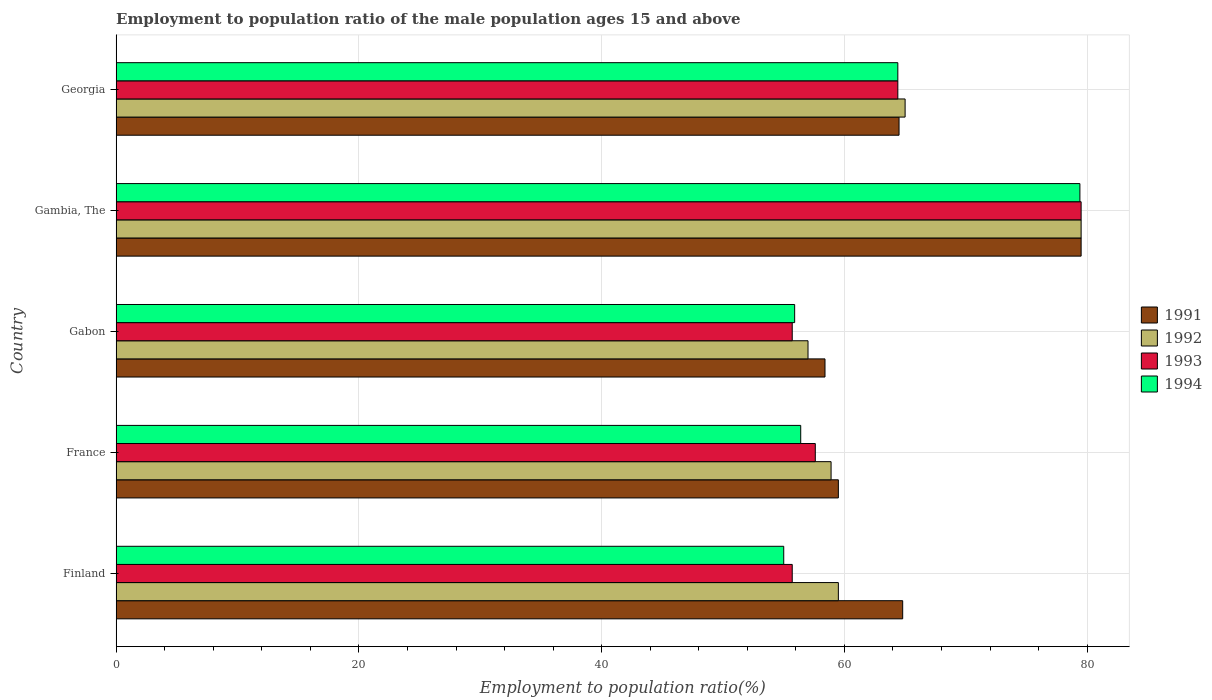How many different coloured bars are there?
Your response must be concise. 4. How many groups of bars are there?
Give a very brief answer. 5. How many bars are there on the 4th tick from the bottom?
Offer a very short reply. 4. What is the label of the 1st group of bars from the top?
Offer a terse response. Georgia. In how many cases, is the number of bars for a given country not equal to the number of legend labels?
Give a very brief answer. 0. Across all countries, what is the maximum employment to population ratio in 1994?
Your answer should be compact. 79.4. Across all countries, what is the minimum employment to population ratio in 1994?
Make the answer very short. 55. In which country was the employment to population ratio in 1992 maximum?
Ensure brevity in your answer.  Gambia, The. In which country was the employment to population ratio in 1994 minimum?
Provide a short and direct response. Finland. What is the total employment to population ratio in 1993 in the graph?
Your answer should be very brief. 312.9. What is the difference between the employment to population ratio in 1994 in Finland and that in Gabon?
Provide a succinct answer. -0.9. What is the difference between the employment to population ratio in 1991 in Georgia and the employment to population ratio in 1992 in France?
Your answer should be compact. 5.6. What is the average employment to population ratio in 1992 per country?
Provide a short and direct response. 63.98. What is the difference between the employment to population ratio in 1991 and employment to population ratio in 1992 in Gabon?
Your answer should be compact. 1.4. What is the ratio of the employment to population ratio in 1994 in France to that in Gabon?
Keep it short and to the point. 1.01. Is the difference between the employment to population ratio in 1991 in Gambia, The and Georgia greater than the difference between the employment to population ratio in 1992 in Gambia, The and Georgia?
Offer a terse response. Yes. Is it the case that in every country, the sum of the employment to population ratio in 1991 and employment to population ratio in 1994 is greater than the sum of employment to population ratio in 1993 and employment to population ratio in 1992?
Your answer should be compact. No. What does the 2nd bar from the top in Gabon represents?
Your response must be concise. 1993. What does the 3rd bar from the bottom in Georgia represents?
Give a very brief answer. 1993. Is it the case that in every country, the sum of the employment to population ratio in 1992 and employment to population ratio in 1991 is greater than the employment to population ratio in 1994?
Make the answer very short. Yes. Are all the bars in the graph horizontal?
Offer a terse response. Yes. What is the title of the graph?
Provide a succinct answer. Employment to population ratio of the male population ages 15 and above. What is the label or title of the X-axis?
Your response must be concise. Employment to population ratio(%). What is the Employment to population ratio(%) of 1991 in Finland?
Provide a succinct answer. 64.8. What is the Employment to population ratio(%) in 1992 in Finland?
Your response must be concise. 59.5. What is the Employment to population ratio(%) of 1993 in Finland?
Offer a very short reply. 55.7. What is the Employment to population ratio(%) of 1994 in Finland?
Offer a terse response. 55. What is the Employment to population ratio(%) of 1991 in France?
Your answer should be compact. 59.5. What is the Employment to population ratio(%) in 1992 in France?
Offer a very short reply. 58.9. What is the Employment to population ratio(%) of 1993 in France?
Your response must be concise. 57.6. What is the Employment to population ratio(%) of 1994 in France?
Provide a succinct answer. 56.4. What is the Employment to population ratio(%) of 1991 in Gabon?
Your response must be concise. 58.4. What is the Employment to population ratio(%) of 1992 in Gabon?
Offer a terse response. 57. What is the Employment to population ratio(%) of 1993 in Gabon?
Keep it short and to the point. 55.7. What is the Employment to population ratio(%) of 1994 in Gabon?
Your answer should be very brief. 55.9. What is the Employment to population ratio(%) of 1991 in Gambia, The?
Provide a short and direct response. 79.5. What is the Employment to population ratio(%) in 1992 in Gambia, The?
Offer a very short reply. 79.5. What is the Employment to population ratio(%) in 1993 in Gambia, The?
Your answer should be very brief. 79.5. What is the Employment to population ratio(%) of 1994 in Gambia, The?
Keep it short and to the point. 79.4. What is the Employment to population ratio(%) of 1991 in Georgia?
Give a very brief answer. 64.5. What is the Employment to population ratio(%) in 1993 in Georgia?
Offer a terse response. 64.4. What is the Employment to population ratio(%) in 1994 in Georgia?
Keep it short and to the point. 64.4. Across all countries, what is the maximum Employment to population ratio(%) of 1991?
Your response must be concise. 79.5. Across all countries, what is the maximum Employment to population ratio(%) of 1992?
Offer a terse response. 79.5. Across all countries, what is the maximum Employment to population ratio(%) of 1993?
Provide a short and direct response. 79.5. Across all countries, what is the maximum Employment to population ratio(%) in 1994?
Provide a short and direct response. 79.4. Across all countries, what is the minimum Employment to population ratio(%) in 1991?
Keep it short and to the point. 58.4. Across all countries, what is the minimum Employment to population ratio(%) in 1993?
Provide a succinct answer. 55.7. Across all countries, what is the minimum Employment to population ratio(%) of 1994?
Offer a terse response. 55. What is the total Employment to population ratio(%) of 1991 in the graph?
Your answer should be compact. 326.7. What is the total Employment to population ratio(%) in 1992 in the graph?
Offer a very short reply. 319.9. What is the total Employment to population ratio(%) of 1993 in the graph?
Ensure brevity in your answer.  312.9. What is the total Employment to population ratio(%) in 1994 in the graph?
Make the answer very short. 311.1. What is the difference between the Employment to population ratio(%) of 1994 in Finland and that in France?
Offer a terse response. -1.4. What is the difference between the Employment to population ratio(%) in 1991 in Finland and that in Gabon?
Your answer should be compact. 6.4. What is the difference between the Employment to population ratio(%) of 1992 in Finland and that in Gabon?
Keep it short and to the point. 2.5. What is the difference between the Employment to population ratio(%) of 1991 in Finland and that in Gambia, The?
Provide a short and direct response. -14.7. What is the difference between the Employment to population ratio(%) of 1992 in Finland and that in Gambia, The?
Make the answer very short. -20. What is the difference between the Employment to population ratio(%) of 1993 in Finland and that in Gambia, The?
Provide a short and direct response. -23.8. What is the difference between the Employment to population ratio(%) of 1994 in Finland and that in Gambia, The?
Offer a terse response. -24.4. What is the difference between the Employment to population ratio(%) in 1991 in Finland and that in Georgia?
Provide a succinct answer. 0.3. What is the difference between the Employment to population ratio(%) of 1993 in Finland and that in Georgia?
Offer a very short reply. -8.7. What is the difference between the Employment to population ratio(%) of 1993 in France and that in Gabon?
Give a very brief answer. 1.9. What is the difference between the Employment to population ratio(%) of 1991 in France and that in Gambia, The?
Provide a succinct answer. -20. What is the difference between the Employment to population ratio(%) in 1992 in France and that in Gambia, The?
Keep it short and to the point. -20.6. What is the difference between the Employment to population ratio(%) in 1993 in France and that in Gambia, The?
Your answer should be compact. -21.9. What is the difference between the Employment to population ratio(%) of 1994 in France and that in Gambia, The?
Give a very brief answer. -23. What is the difference between the Employment to population ratio(%) of 1992 in France and that in Georgia?
Offer a very short reply. -6.1. What is the difference between the Employment to population ratio(%) of 1991 in Gabon and that in Gambia, The?
Make the answer very short. -21.1. What is the difference between the Employment to population ratio(%) of 1992 in Gabon and that in Gambia, The?
Offer a terse response. -22.5. What is the difference between the Employment to population ratio(%) in 1993 in Gabon and that in Gambia, The?
Keep it short and to the point. -23.8. What is the difference between the Employment to population ratio(%) in 1994 in Gabon and that in Gambia, The?
Offer a terse response. -23.5. What is the difference between the Employment to population ratio(%) of 1991 in Gabon and that in Georgia?
Give a very brief answer. -6.1. What is the difference between the Employment to population ratio(%) in 1994 in Gabon and that in Georgia?
Your response must be concise. -8.5. What is the difference between the Employment to population ratio(%) of 1993 in Gambia, The and that in Georgia?
Give a very brief answer. 15.1. What is the difference between the Employment to population ratio(%) of 1991 in Finland and the Employment to population ratio(%) of 1994 in France?
Provide a succinct answer. 8.4. What is the difference between the Employment to population ratio(%) of 1992 in Finland and the Employment to population ratio(%) of 1994 in France?
Give a very brief answer. 3.1. What is the difference between the Employment to population ratio(%) of 1991 in Finland and the Employment to population ratio(%) of 1992 in Gabon?
Ensure brevity in your answer.  7.8. What is the difference between the Employment to population ratio(%) of 1991 in Finland and the Employment to population ratio(%) of 1993 in Gabon?
Make the answer very short. 9.1. What is the difference between the Employment to population ratio(%) in 1993 in Finland and the Employment to population ratio(%) in 1994 in Gabon?
Keep it short and to the point. -0.2. What is the difference between the Employment to population ratio(%) in 1991 in Finland and the Employment to population ratio(%) in 1992 in Gambia, The?
Provide a succinct answer. -14.7. What is the difference between the Employment to population ratio(%) in 1991 in Finland and the Employment to population ratio(%) in 1993 in Gambia, The?
Offer a very short reply. -14.7. What is the difference between the Employment to population ratio(%) of 1991 in Finland and the Employment to population ratio(%) of 1994 in Gambia, The?
Give a very brief answer. -14.6. What is the difference between the Employment to population ratio(%) in 1992 in Finland and the Employment to population ratio(%) in 1993 in Gambia, The?
Give a very brief answer. -20. What is the difference between the Employment to population ratio(%) in 1992 in Finland and the Employment to population ratio(%) in 1994 in Gambia, The?
Offer a terse response. -19.9. What is the difference between the Employment to population ratio(%) in 1993 in Finland and the Employment to population ratio(%) in 1994 in Gambia, The?
Your answer should be compact. -23.7. What is the difference between the Employment to population ratio(%) in 1991 in Finland and the Employment to population ratio(%) in 1992 in Georgia?
Offer a very short reply. -0.2. What is the difference between the Employment to population ratio(%) of 1991 in Finland and the Employment to population ratio(%) of 1994 in Georgia?
Make the answer very short. 0.4. What is the difference between the Employment to population ratio(%) in 1992 in Finland and the Employment to population ratio(%) in 1993 in Georgia?
Your answer should be compact. -4.9. What is the difference between the Employment to population ratio(%) in 1992 in Finland and the Employment to population ratio(%) in 1994 in Georgia?
Keep it short and to the point. -4.9. What is the difference between the Employment to population ratio(%) of 1991 in France and the Employment to population ratio(%) of 1992 in Gabon?
Keep it short and to the point. 2.5. What is the difference between the Employment to population ratio(%) in 1991 in France and the Employment to population ratio(%) in 1994 in Gabon?
Provide a succinct answer. 3.6. What is the difference between the Employment to population ratio(%) in 1992 in France and the Employment to population ratio(%) in 1993 in Gabon?
Your answer should be compact. 3.2. What is the difference between the Employment to population ratio(%) of 1992 in France and the Employment to population ratio(%) of 1994 in Gabon?
Your answer should be very brief. 3. What is the difference between the Employment to population ratio(%) of 1993 in France and the Employment to population ratio(%) of 1994 in Gabon?
Your response must be concise. 1.7. What is the difference between the Employment to population ratio(%) of 1991 in France and the Employment to population ratio(%) of 1992 in Gambia, The?
Give a very brief answer. -20. What is the difference between the Employment to population ratio(%) in 1991 in France and the Employment to population ratio(%) in 1993 in Gambia, The?
Provide a short and direct response. -20. What is the difference between the Employment to population ratio(%) of 1991 in France and the Employment to population ratio(%) of 1994 in Gambia, The?
Your answer should be compact. -19.9. What is the difference between the Employment to population ratio(%) of 1992 in France and the Employment to population ratio(%) of 1993 in Gambia, The?
Provide a succinct answer. -20.6. What is the difference between the Employment to population ratio(%) in 1992 in France and the Employment to population ratio(%) in 1994 in Gambia, The?
Provide a succinct answer. -20.5. What is the difference between the Employment to population ratio(%) in 1993 in France and the Employment to population ratio(%) in 1994 in Gambia, The?
Give a very brief answer. -21.8. What is the difference between the Employment to population ratio(%) of 1991 in France and the Employment to population ratio(%) of 1993 in Georgia?
Offer a very short reply. -4.9. What is the difference between the Employment to population ratio(%) of 1992 in France and the Employment to population ratio(%) of 1993 in Georgia?
Offer a terse response. -5.5. What is the difference between the Employment to population ratio(%) of 1992 in France and the Employment to population ratio(%) of 1994 in Georgia?
Your answer should be compact. -5.5. What is the difference between the Employment to population ratio(%) in 1993 in France and the Employment to population ratio(%) in 1994 in Georgia?
Your answer should be very brief. -6.8. What is the difference between the Employment to population ratio(%) of 1991 in Gabon and the Employment to population ratio(%) of 1992 in Gambia, The?
Give a very brief answer. -21.1. What is the difference between the Employment to population ratio(%) of 1991 in Gabon and the Employment to population ratio(%) of 1993 in Gambia, The?
Your answer should be very brief. -21.1. What is the difference between the Employment to population ratio(%) of 1992 in Gabon and the Employment to population ratio(%) of 1993 in Gambia, The?
Offer a terse response. -22.5. What is the difference between the Employment to population ratio(%) of 1992 in Gabon and the Employment to population ratio(%) of 1994 in Gambia, The?
Ensure brevity in your answer.  -22.4. What is the difference between the Employment to population ratio(%) in 1993 in Gabon and the Employment to population ratio(%) in 1994 in Gambia, The?
Ensure brevity in your answer.  -23.7. What is the difference between the Employment to population ratio(%) in 1991 in Gabon and the Employment to population ratio(%) in 1994 in Georgia?
Provide a short and direct response. -6. What is the difference between the Employment to population ratio(%) of 1992 in Gabon and the Employment to population ratio(%) of 1994 in Georgia?
Your answer should be very brief. -7.4. What is the difference between the Employment to population ratio(%) in 1991 in Gambia, The and the Employment to population ratio(%) in 1994 in Georgia?
Provide a short and direct response. 15.1. What is the difference between the Employment to population ratio(%) of 1992 in Gambia, The and the Employment to population ratio(%) of 1993 in Georgia?
Your answer should be compact. 15.1. What is the difference between the Employment to population ratio(%) of 1992 in Gambia, The and the Employment to population ratio(%) of 1994 in Georgia?
Keep it short and to the point. 15.1. What is the average Employment to population ratio(%) in 1991 per country?
Ensure brevity in your answer.  65.34. What is the average Employment to population ratio(%) in 1992 per country?
Your answer should be very brief. 63.98. What is the average Employment to population ratio(%) of 1993 per country?
Offer a very short reply. 62.58. What is the average Employment to population ratio(%) in 1994 per country?
Your answer should be compact. 62.22. What is the difference between the Employment to population ratio(%) of 1991 and Employment to population ratio(%) of 1993 in Finland?
Your answer should be compact. 9.1. What is the difference between the Employment to population ratio(%) in 1991 and Employment to population ratio(%) in 1994 in Finland?
Offer a very short reply. 9.8. What is the difference between the Employment to population ratio(%) of 1991 and Employment to population ratio(%) of 1992 in France?
Offer a very short reply. 0.6. What is the difference between the Employment to population ratio(%) of 1992 and Employment to population ratio(%) of 1994 in France?
Offer a very short reply. 2.5. What is the difference between the Employment to population ratio(%) in 1992 and Employment to population ratio(%) in 1993 in Gabon?
Make the answer very short. 1.3. What is the difference between the Employment to population ratio(%) of 1992 and Employment to population ratio(%) of 1994 in Gabon?
Make the answer very short. 1.1. What is the difference between the Employment to population ratio(%) of 1993 and Employment to population ratio(%) of 1994 in Gabon?
Provide a short and direct response. -0.2. What is the difference between the Employment to population ratio(%) of 1991 and Employment to population ratio(%) of 1992 in Gambia, The?
Your answer should be very brief. 0. What is the difference between the Employment to population ratio(%) of 1991 and Employment to population ratio(%) of 1993 in Gambia, The?
Provide a short and direct response. 0. What is the difference between the Employment to population ratio(%) of 1992 and Employment to population ratio(%) of 1993 in Gambia, The?
Ensure brevity in your answer.  0. What is the difference between the Employment to population ratio(%) in 1992 and Employment to population ratio(%) in 1994 in Gambia, The?
Your response must be concise. 0.1. What is the difference between the Employment to population ratio(%) in 1993 and Employment to population ratio(%) in 1994 in Gambia, The?
Give a very brief answer. 0.1. What is the difference between the Employment to population ratio(%) of 1991 and Employment to population ratio(%) of 1992 in Georgia?
Give a very brief answer. -0.5. What is the difference between the Employment to population ratio(%) of 1991 and Employment to population ratio(%) of 1993 in Georgia?
Ensure brevity in your answer.  0.1. What is the difference between the Employment to population ratio(%) of 1992 and Employment to population ratio(%) of 1994 in Georgia?
Provide a succinct answer. 0.6. What is the difference between the Employment to population ratio(%) of 1993 and Employment to population ratio(%) of 1994 in Georgia?
Your response must be concise. 0. What is the ratio of the Employment to population ratio(%) in 1991 in Finland to that in France?
Give a very brief answer. 1.09. What is the ratio of the Employment to population ratio(%) in 1992 in Finland to that in France?
Your answer should be compact. 1.01. What is the ratio of the Employment to population ratio(%) of 1993 in Finland to that in France?
Give a very brief answer. 0.97. What is the ratio of the Employment to population ratio(%) of 1994 in Finland to that in France?
Ensure brevity in your answer.  0.98. What is the ratio of the Employment to population ratio(%) in 1991 in Finland to that in Gabon?
Offer a terse response. 1.11. What is the ratio of the Employment to population ratio(%) in 1992 in Finland to that in Gabon?
Your response must be concise. 1.04. What is the ratio of the Employment to population ratio(%) in 1994 in Finland to that in Gabon?
Your response must be concise. 0.98. What is the ratio of the Employment to population ratio(%) of 1991 in Finland to that in Gambia, The?
Your response must be concise. 0.82. What is the ratio of the Employment to population ratio(%) in 1992 in Finland to that in Gambia, The?
Provide a short and direct response. 0.75. What is the ratio of the Employment to population ratio(%) of 1993 in Finland to that in Gambia, The?
Keep it short and to the point. 0.7. What is the ratio of the Employment to population ratio(%) in 1994 in Finland to that in Gambia, The?
Keep it short and to the point. 0.69. What is the ratio of the Employment to population ratio(%) of 1991 in Finland to that in Georgia?
Make the answer very short. 1. What is the ratio of the Employment to population ratio(%) in 1992 in Finland to that in Georgia?
Provide a short and direct response. 0.92. What is the ratio of the Employment to population ratio(%) of 1993 in Finland to that in Georgia?
Ensure brevity in your answer.  0.86. What is the ratio of the Employment to population ratio(%) in 1994 in Finland to that in Georgia?
Your answer should be compact. 0.85. What is the ratio of the Employment to population ratio(%) of 1991 in France to that in Gabon?
Your answer should be compact. 1.02. What is the ratio of the Employment to population ratio(%) in 1992 in France to that in Gabon?
Your answer should be very brief. 1.03. What is the ratio of the Employment to population ratio(%) of 1993 in France to that in Gabon?
Keep it short and to the point. 1.03. What is the ratio of the Employment to population ratio(%) of 1994 in France to that in Gabon?
Provide a succinct answer. 1.01. What is the ratio of the Employment to population ratio(%) in 1991 in France to that in Gambia, The?
Make the answer very short. 0.75. What is the ratio of the Employment to population ratio(%) in 1992 in France to that in Gambia, The?
Offer a very short reply. 0.74. What is the ratio of the Employment to population ratio(%) in 1993 in France to that in Gambia, The?
Your response must be concise. 0.72. What is the ratio of the Employment to population ratio(%) in 1994 in France to that in Gambia, The?
Your response must be concise. 0.71. What is the ratio of the Employment to population ratio(%) in 1991 in France to that in Georgia?
Ensure brevity in your answer.  0.92. What is the ratio of the Employment to population ratio(%) in 1992 in France to that in Georgia?
Your response must be concise. 0.91. What is the ratio of the Employment to population ratio(%) in 1993 in France to that in Georgia?
Provide a succinct answer. 0.89. What is the ratio of the Employment to population ratio(%) in 1994 in France to that in Georgia?
Provide a short and direct response. 0.88. What is the ratio of the Employment to population ratio(%) in 1991 in Gabon to that in Gambia, The?
Keep it short and to the point. 0.73. What is the ratio of the Employment to population ratio(%) of 1992 in Gabon to that in Gambia, The?
Give a very brief answer. 0.72. What is the ratio of the Employment to population ratio(%) of 1993 in Gabon to that in Gambia, The?
Keep it short and to the point. 0.7. What is the ratio of the Employment to population ratio(%) of 1994 in Gabon to that in Gambia, The?
Offer a very short reply. 0.7. What is the ratio of the Employment to population ratio(%) of 1991 in Gabon to that in Georgia?
Ensure brevity in your answer.  0.91. What is the ratio of the Employment to population ratio(%) in 1992 in Gabon to that in Georgia?
Offer a very short reply. 0.88. What is the ratio of the Employment to population ratio(%) of 1993 in Gabon to that in Georgia?
Give a very brief answer. 0.86. What is the ratio of the Employment to population ratio(%) in 1994 in Gabon to that in Georgia?
Provide a succinct answer. 0.87. What is the ratio of the Employment to population ratio(%) of 1991 in Gambia, The to that in Georgia?
Offer a very short reply. 1.23. What is the ratio of the Employment to population ratio(%) in 1992 in Gambia, The to that in Georgia?
Provide a short and direct response. 1.22. What is the ratio of the Employment to population ratio(%) in 1993 in Gambia, The to that in Georgia?
Provide a short and direct response. 1.23. What is the ratio of the Employment to population ratio(%) of 1994 in Gambia, The to that in Georgia?
Offer a terse response. 1.23. What is the difference between the highest and the second highest Employment to population ratio(%) in 1991?
Provide a short and direct response. 14.7. What is the difference between the highest and the second highest Employment to population ratio(%) in 1992?
Give a very brief answer. 14.5. What is the difference between the highest and the second highest Employment to population ratio(%) in 1993?
Ensure brevity in your answer.  15.1. What is the difference between the highest and the second highest Employment to population ratio(%) of 1994?
Provide a succinct answer. 15. What is the difference between the highest and the lowest Employment to population ratio(%) in 1991?
Provide a succinct answer. 21.1. What is the difference between the highest and the lowest Employment to population ratio(%) of 1993?
Ensure brevity in your answer.  23.8. What is the difference between the highest and the lowest Employment to population ratio(%) of 1994?
Your answer should be compact. 24.4. 